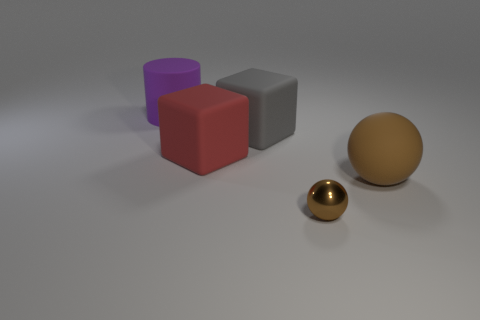Is there a small metal thing of the same shape as the gray rubber object?
Your response must be concise. No. There is a brown object in front of the large ball; is it the same shape as the object that is on the right side of the small metal object?
Provide a succinct answer. Yes. Is there a green rubber ball of the same size as the brown rubber ball?
Your response must be concise. No. Is the number of big gray rubber things on the right side of the large red matte thing the same as the number of tiny metal spheres that are left of the gray object?
Offer a terse response. No. Do the block that is on the left side of the big gray matte thing and the brown thing in front of the large sphere have the same material?
Ensure brevity in your answer.  No. What is the material of the big brown sphere?
Give a very brief answer. Rubber. How many other objects are there of the same color as the cylinder?
Make the answer very short. 0. Does the tiny metal ball have the same color as the big cylinder?
Your answer should be very brief. No. How many blue shiny cylinders are there?
Your answer should be compact. 0. What is the material of the ball on the left side of the large thing right of the large gray cube?
Offer a very short reply. Metal. 